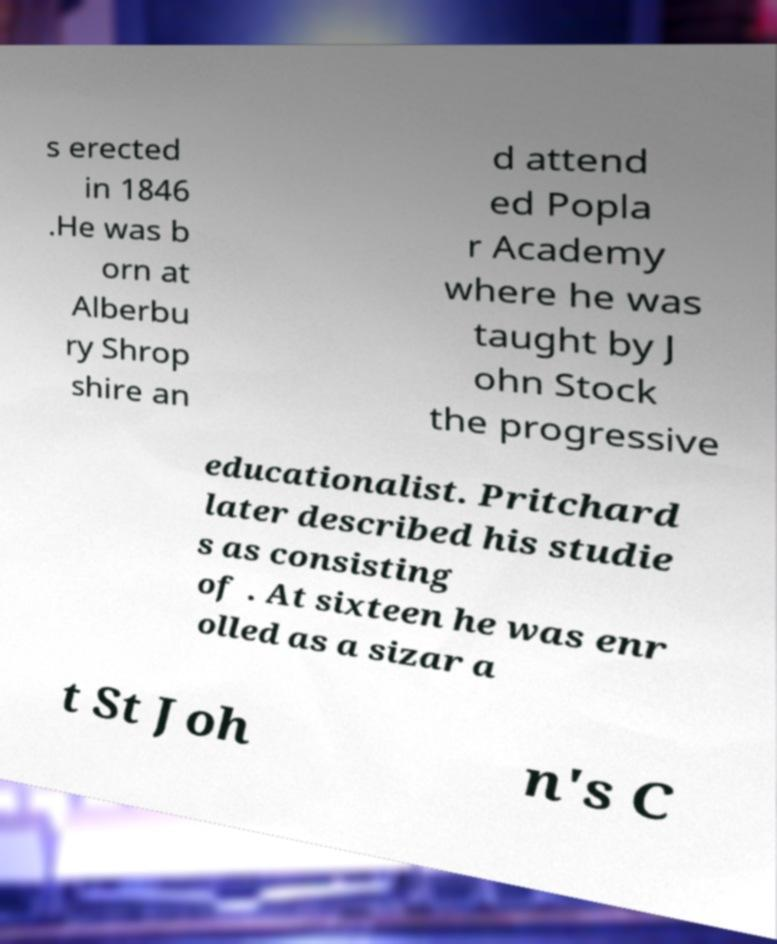There's text embedded in this image that I need extracted. Can you transcribe it verbatim? s erected in 1846 .He was b orn at Alberbu ry Shrop shire an d attend ed Popla r Academy where he was taught by J ohn Stock the progressive educationalist. Pritchard later described his studie s as consisting of . At sixteen he was enr olled as a sizar a t St Joh n's C 